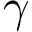<formula> <loc_0><loc_0><loc_500><loc_500>\gamma</formula> 